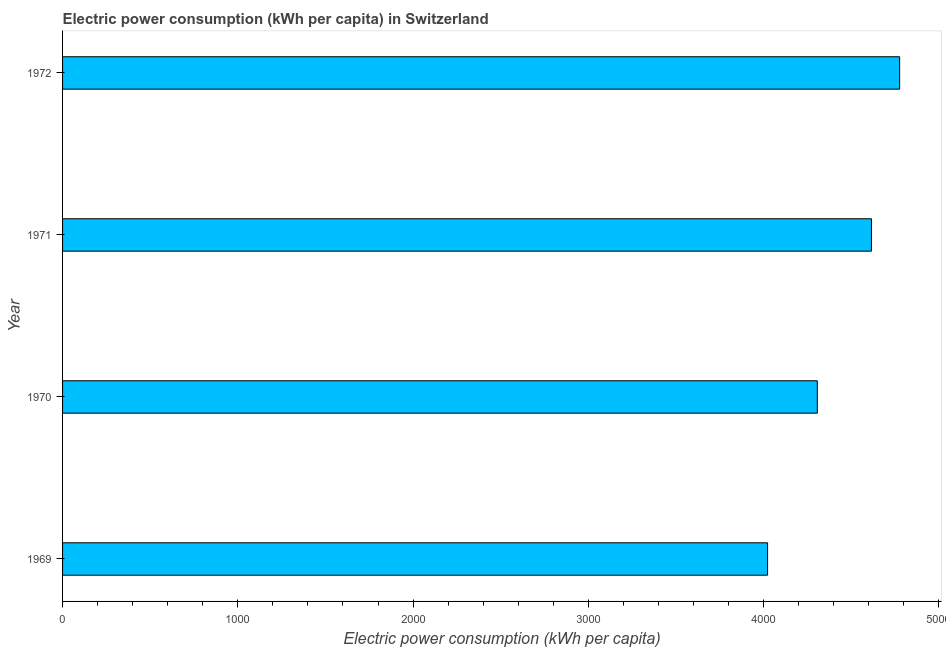Does the graph contain any zero values?
Provide a short and direct response. No. What is the title of the graph?
Offer a terse response. Electric power consumption (kWh per capita) in Switzerland. What is the label or title of the X-axis?
Give a very brief answer. Electric power consumption (kWh per capita). What is the label or title of the Y-axis?
Your answer should be compact. Year. What is the electric power consumption in 1969?
Provide a succinct answer. 4022.73. Across all years, what is the maximum electric power consumption?
Keep it short and to the point. 4776.27. Across all years, what is the minimum electric power consumption?
Ensure brevity in your answer.  4022.73. In which year was the electric power consumption minimum?
Offer a very short reply. 1969. What is the sum of the electric power consumption?
Make the answer very short. 1.77e+04. What is the difference between the electric power consumption in 1969 and 1970?
Provide a short and direct response. -283.78. What is the average electric power consumption per year?
Provide a short and direct response. 4430.21. What is the median electric power consumption?
Offer a terse response. 4460.93. What is the ratio of the electric power consumption in 1970 to that in 1972?
Offer a very short reply. 0.9. Is the electric power consumption in 1970 less than that in 1971?
Your response must be concise. Yes. Is the difference between the electric power consumption in 1970 and 1972 greater than the difference between any two years?
Provide a short and direct response. No. What is the difference between the highest and the second highest electric power consumption?
Provide a short and direct response. 160.92. What is the difference between the highest and the lowest electric power consumption?
Your answer should be very brief. 753.54. Are all the bars in the graph horizontal?
Offer a very short reply. Yes. How many years are there in the graph?
Offer a very short reply. 4. Are the values on the major ticks of X-axis written in scientific E-notation?
Ensure brevity in your answer.  No. What is the Electric power consumption (kWh per capita) of 1969?
Offer a very short reply. 4022.73. What is the Electric power consumption (kWh per capita) in 1970?
Provide a short and direct response. 4306.51. What is the Electric power consumption (kWh per capita) in 1971?
Your response must be concise. 4615.35. What is the Electric power consumption (kWh per capita) of 1972?
Give a very brief answer. 4776.27. What is the difference between the Electric power consumption (kWh per capita) in 1969 and 1970?
Give a very brief answer. -283.78. What is the difference between the Electric power consumption (kWh per capita) in 1969 and 1971?
Your response must be concise. -592.62. What is the difference between the Electric power consumption (kWh per capita) in 1969 and 1972?
Make the answer very short. -753.54. What is the difference between the Electric power consumption (kWh per capita) in 1970 and 1971?
Provide a short and direct response. -308.84. What is the difference between the Electric power consumption (kWh per capita) in 1970 and 1972?
Make the answer very short. -469.76. What is the difference between the Electric power consumption (kWh per capita) in 1971 and 1972?
Offer a very short reply. -160.92. What is the ratio of the Electric power consumption (kWh per capita) in 1969 to that in 1970?
Your answer should be compact. 0.93. What is the ratio of the Electric power consumption (kWh per capita) in 1969 to that in 1971?
Your answer should be very brief. 0.87. What is the ratio of the Electric power consumption (kWh per capita) in 1969 to that in 1972?
Your answer should be compact. 0.84. What is the ratio of the Electric power consumption (kWh per capita) in 1970 to that in 1971?
Give a very brief answer. 0.93. What is the ratio of the Electric power consumption (kWh per capita) in 1970 to that in 1972?
Provide a succinct answer. 0.9. What is the ratio of the Electric power consumption (kWh per capita) in 1971 to that in 1972?
Your response must be concise. 0.97. 